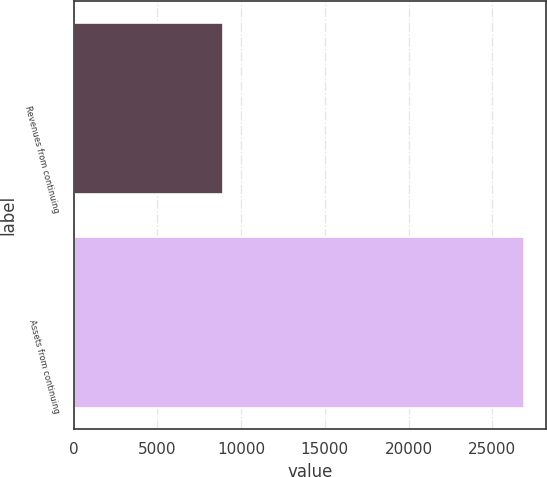Convert chart to OTSL. <chart><loc_0><loc_0><loc_500><loc_500><bar_chart><fcel>Revenues from continuing<fcel>Assets from continuing<nl><fcel>8927.7<fcel>26862.2<nl></chart> 